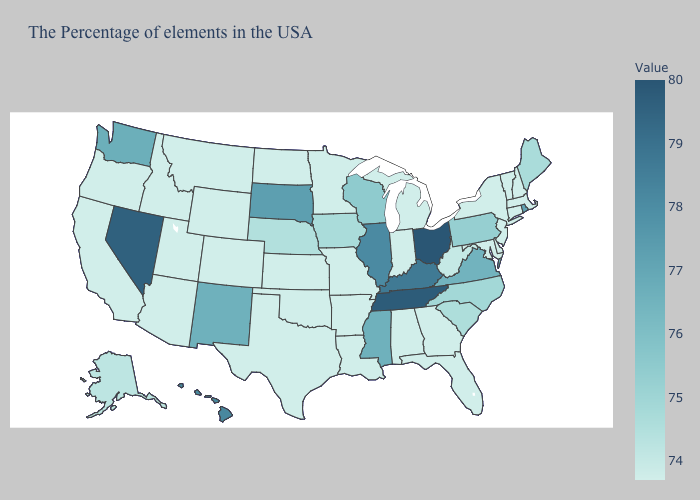Does South Carolina have the lowest value in the South?
Quick response, please. No. Among the states that border Texas , which have the highest value?
Short answer required. New Mexico. Does Wisconsin have a higher value than South Dakota?
Keep it brief. No. Which states have the lowest value in the South?
Give a very brief answer. Delaware, Maryland, Florida, Georgia, Alabama, Louisiana, Arkansas, Oklahoma, Texas. Which states have the highest value in the USA?
Write a very short answer. Ohio. Which states have the lowest value in the West?
Write a very short answer. Wyoming, Colorado, Utah, Montana, Arizona, Idaho, California, Oregon. Among the states that border West Virginia , does Maryland have the lowest value?
Keep it brief. Yes. Is the legend a continuous bar?
Be succinct. Yes. Which states have the lowest value in the USA?
Be succinct. Massachusetts, New Hampshire, Vermont, Connecticut, New York, New Jersey, Delaware, Maryland, Florida, Georgia, Michigan, Indiana, Alabama, Louisiana, Missouri, Arkansas, Minnesota, Kansas, Oklahoma, Texas, North Dakota, Wyoming, Colorado, Utah, Montana, Arizona, Idaho, California, Oregon. 